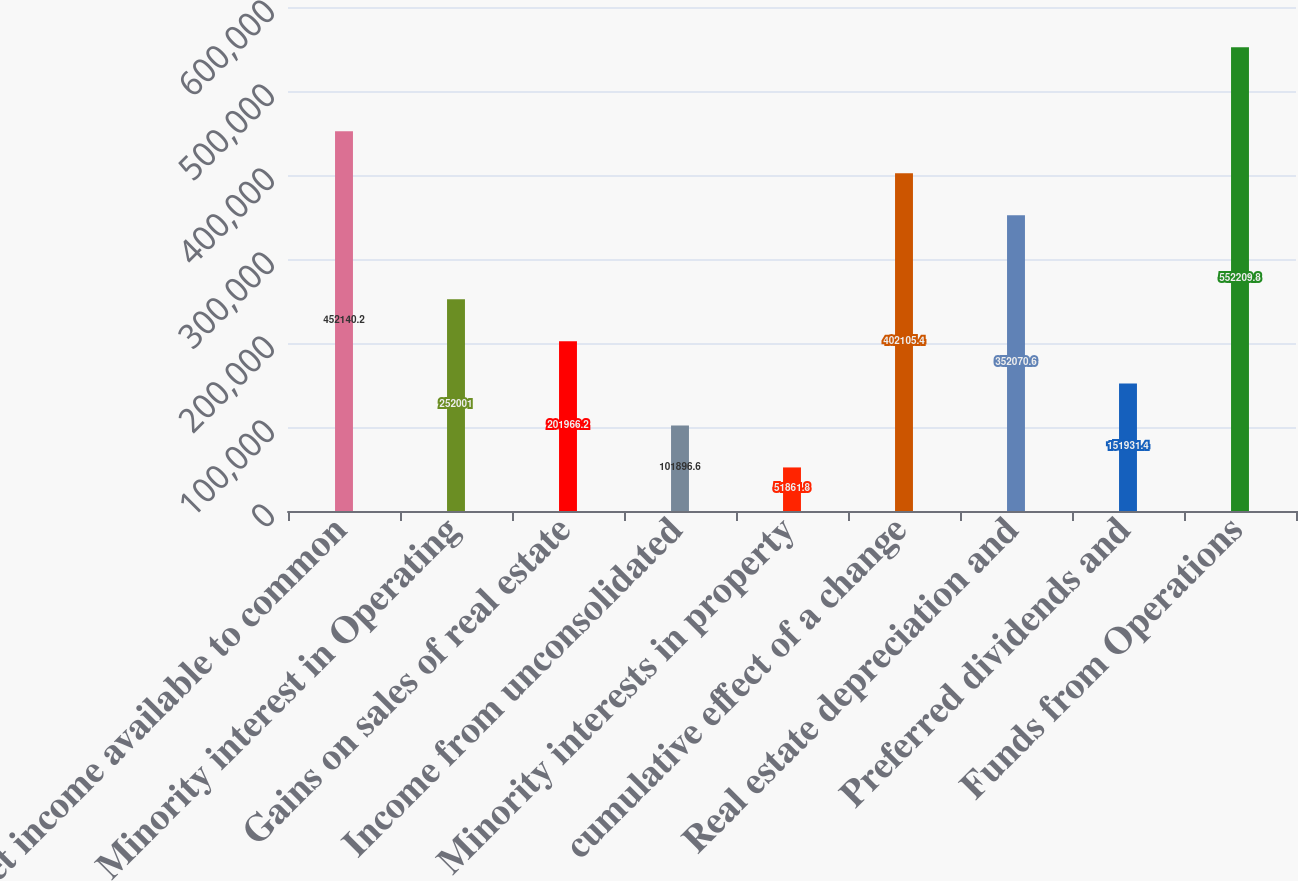Convert chart to OTSL. <chart><loc_0><loc_0><loc_500><loc_500><bar_chart><fcel>Net income available to common<fcel>Minority interest in Operating<fcel>Gains on sales of real estate<fcel>Income from unconsolidated<fcel>Minority interests in property<fcel>cumulative effect of a change<fcel>Real estate depreciation and<fcel>Preferred dividends and<fcel>Funds from Operations<nl><fcel>452140<fcel>252001<fcel>201966<fcel>101897<fcel>51861.8<fcel>402105<fcel>352071<fcel>151931<fcel>552210<nl></chart> 